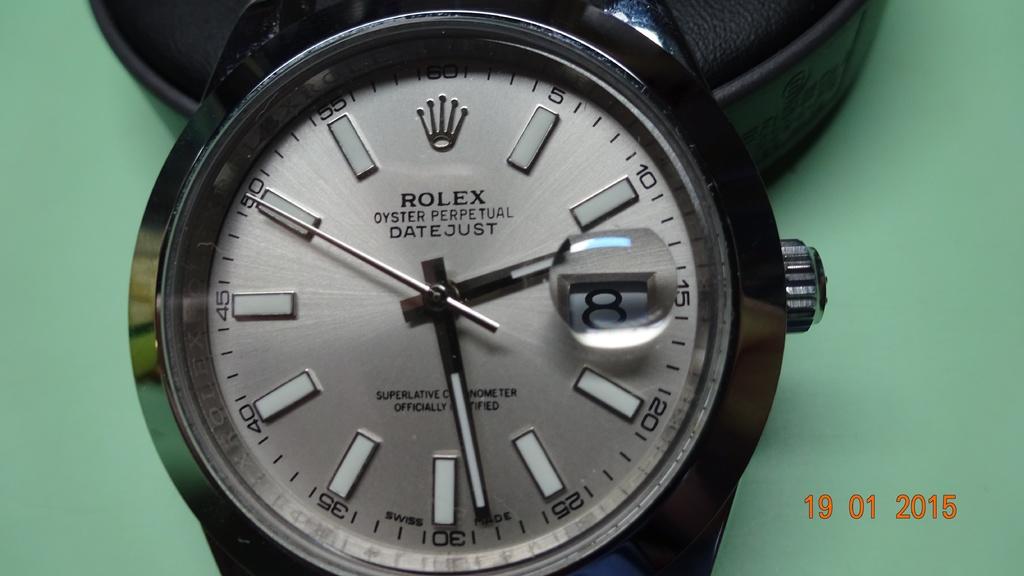What is the watch brand under the logo?
Make the answer very short. Rolex. What year was this photo taken?
Your answer should be very brief. 2015. 